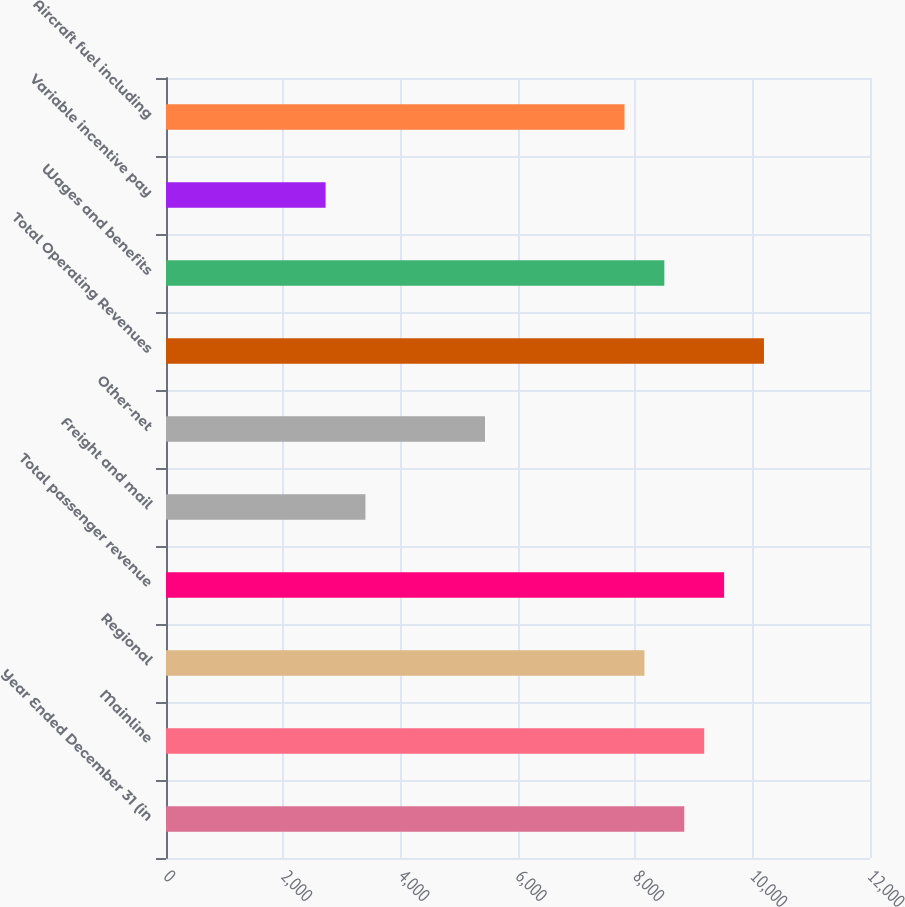Convert chart. <chart><loc_0><loc_0><loc_500><loc_500><bar_chart><fcel>Year Ended December 31 (in<fcel>Mainline<fcel>Regional<fcel>Total passenger revenue<fcel>Freight and mail<fcel>Other-net<fcel>Total Operating Revenues<fcel>Wages and benefits<fcel>Variable incentive pay<fcel>Aircraft fuel including<nl><fcel>8834<fcel>9173.64<fcel>8154.72<fcel>9513.28<fcel>3399.76<fcel>5437.6<fcel>10192.6<fcel>8494.36<fcel>2720.48<fcel>7815.08<nl></chart> 